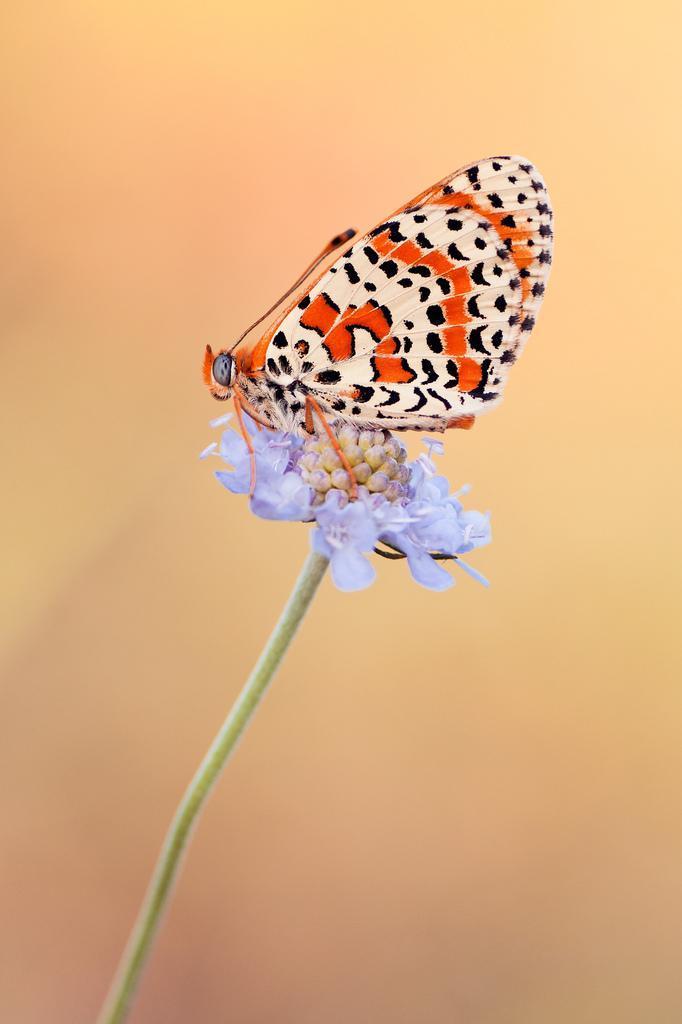In one or two sentences, can you explain what this image depicts? In the image we can see there is a butterfly sitting on the flower and background of the image is blurred. 